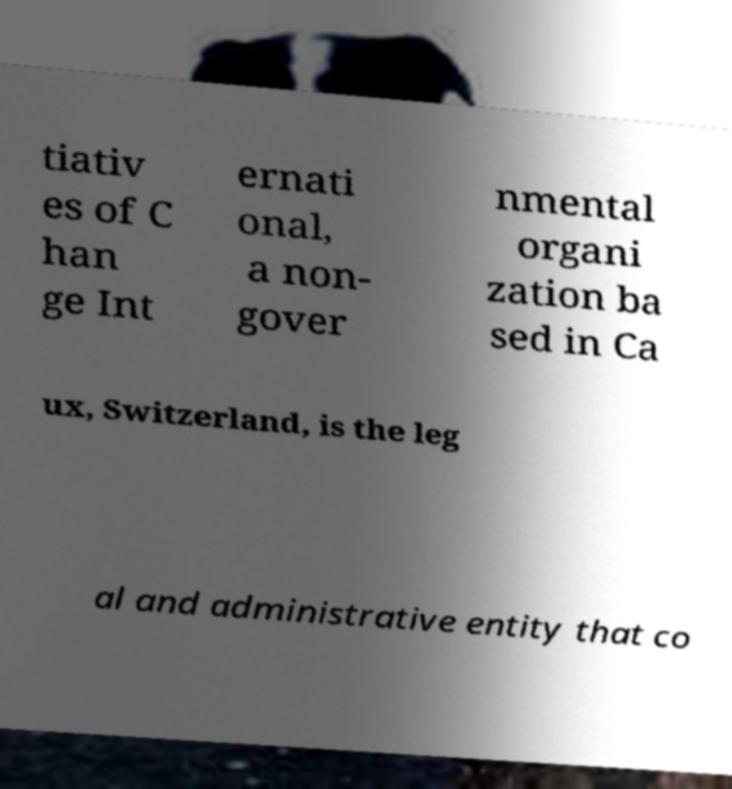Can you accurately transcribe the text from the provided image for me? tiativ es of C han ge Int ernati onal, a non- gover nmental organi zation ba sed in Ca ux, Switzerland, is the leg al and administrative entity that co 